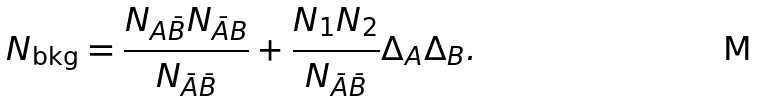<formula> <loc_0><loc_0><loc_500><loc_500>N _ { \text {bkg} } = \frac { N _ { A \bar { B } } N _ { \bar { A } B } } { N _ { \bar { A } \bar { B } } } + \frac { N _ { 1 } N _ { 2 } } { N _ { \bar { A } \bar { B } } } \Delta _ { A } \Delta _ { B } .</formula> 